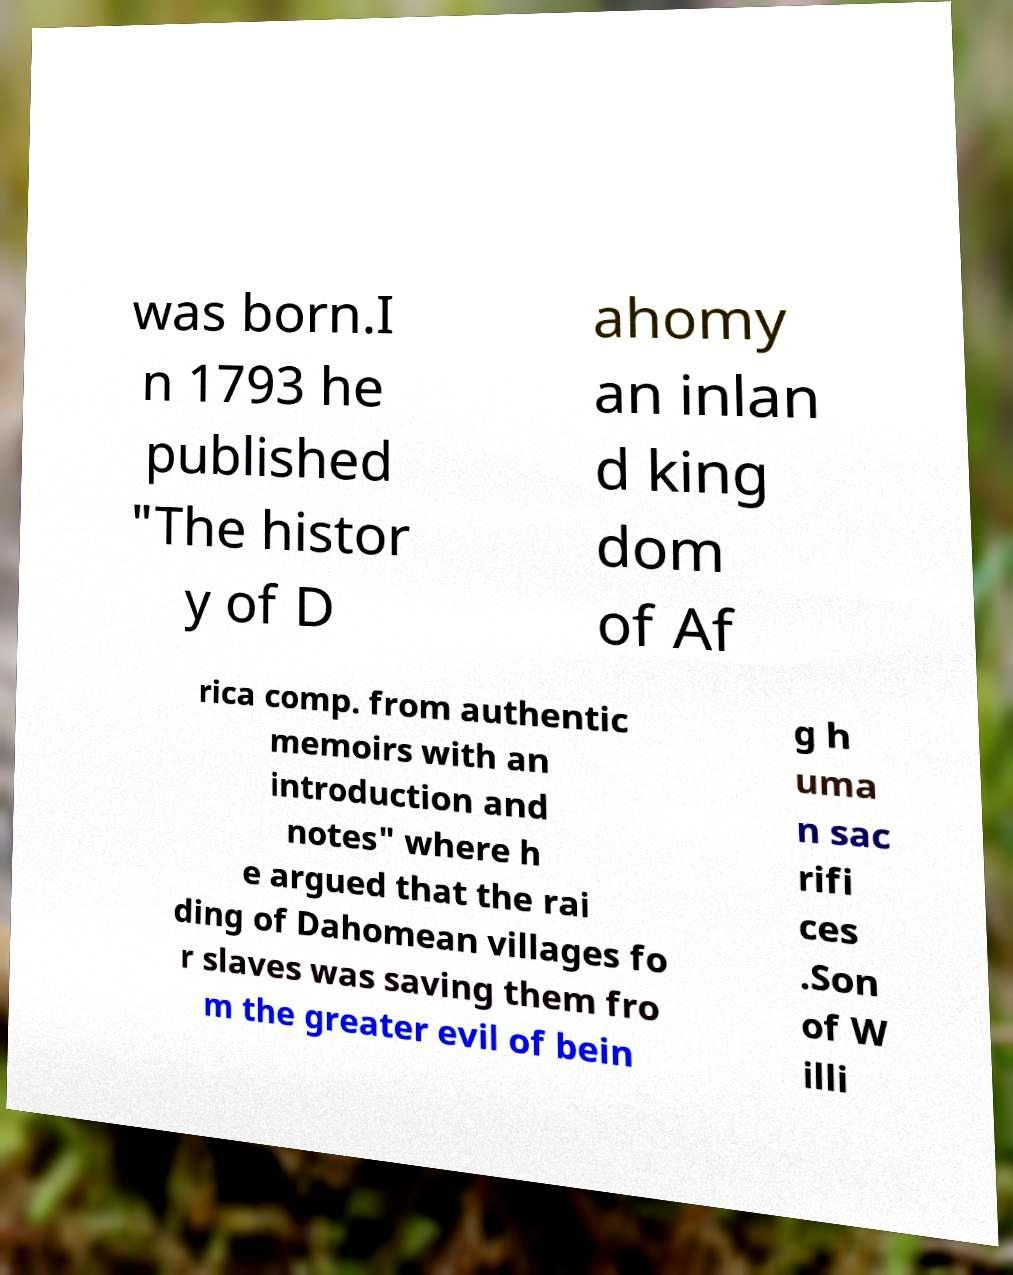Can you read and provide the text displayed in the image?This photo seems to have some interesting text. Can you extract and type it out for me? was born.I n 1793 he published "The histor y of D ahomy an inlan d king dom of Af rica comp. from authentic memoirs with an introduction and notes" where h e argued that the rai ding of Dahomean villages fo r slaves was saving them fro m the greater evil of bein g h uma n sac rifi ces .Son of W illi 